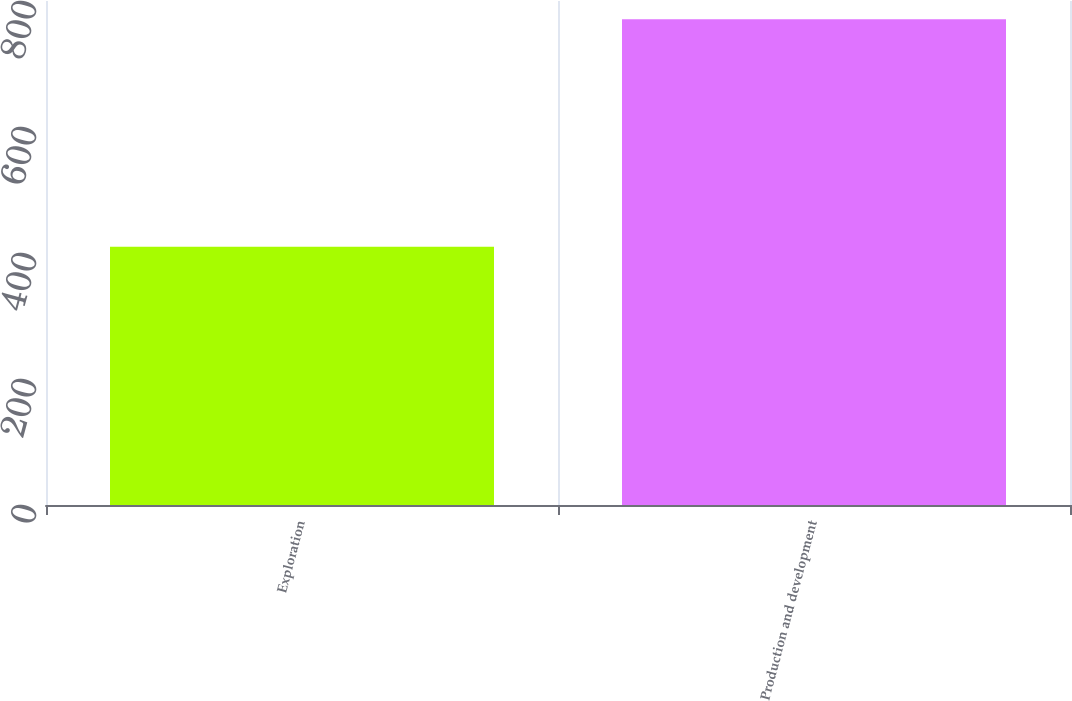<chart> <loc_0><loc_0><loc_500><loc_500><bar_chart><fcel>Exploration<fcel>Production and development<nl><fcel>410<fcel>771<nl></chart> 